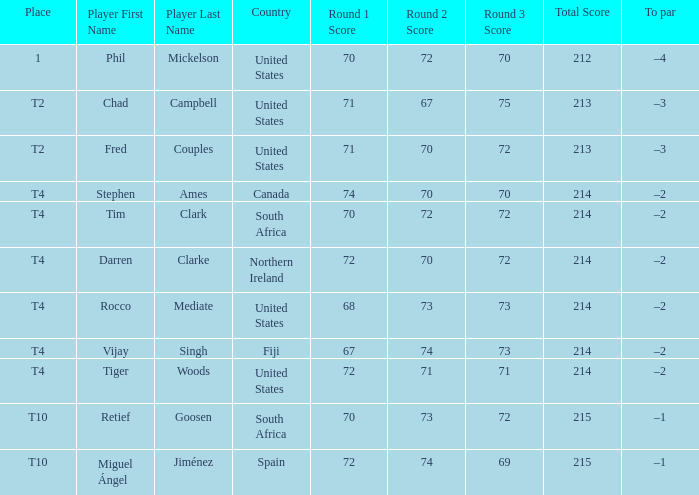What was the score for Spain? 72-74-69=215. 